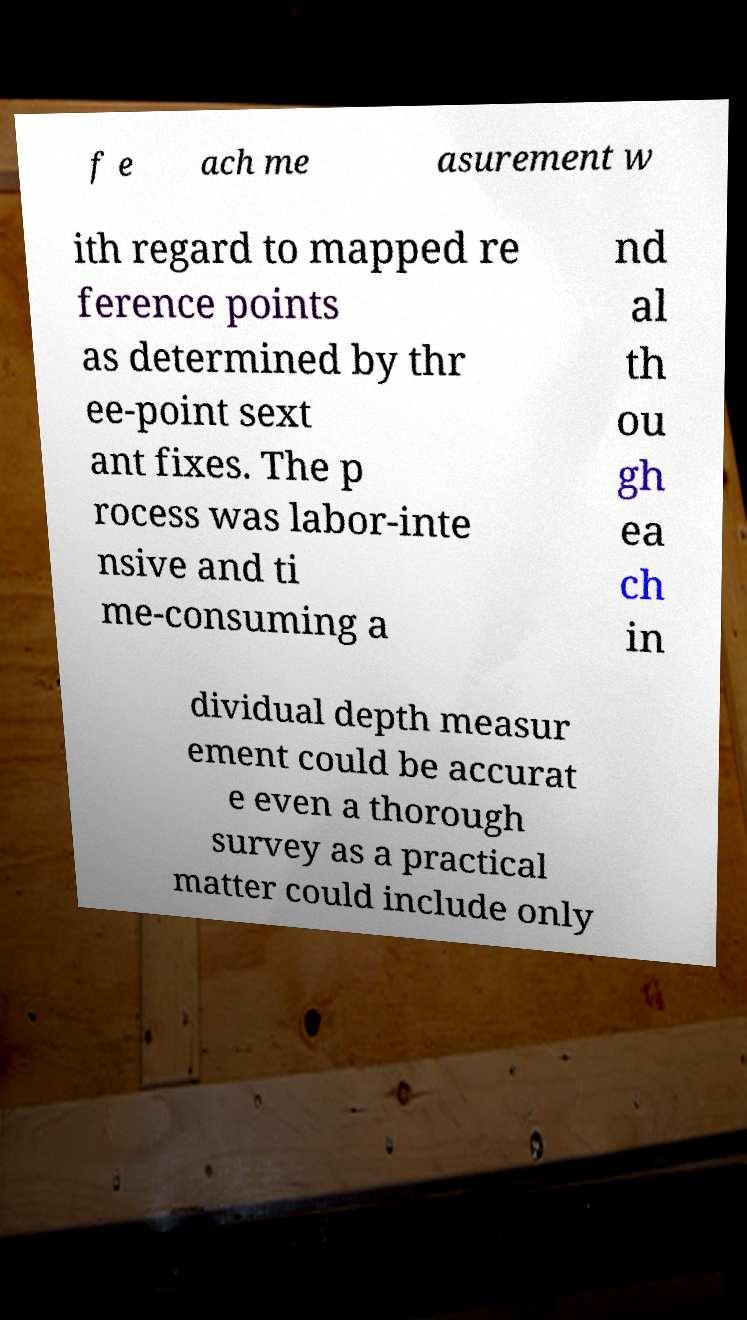Please identify and transcribe the text found in this image. f e ach me asurement w ith regard to mapped re ference points as determined by thr ee-point sext ant fixes. The p rocess was labor-inte nsive and ti me-consuming a nd al th ou gh ea ch in dividual depth measur ement could be accurat e even a thorough survey as a practical matter could include only 